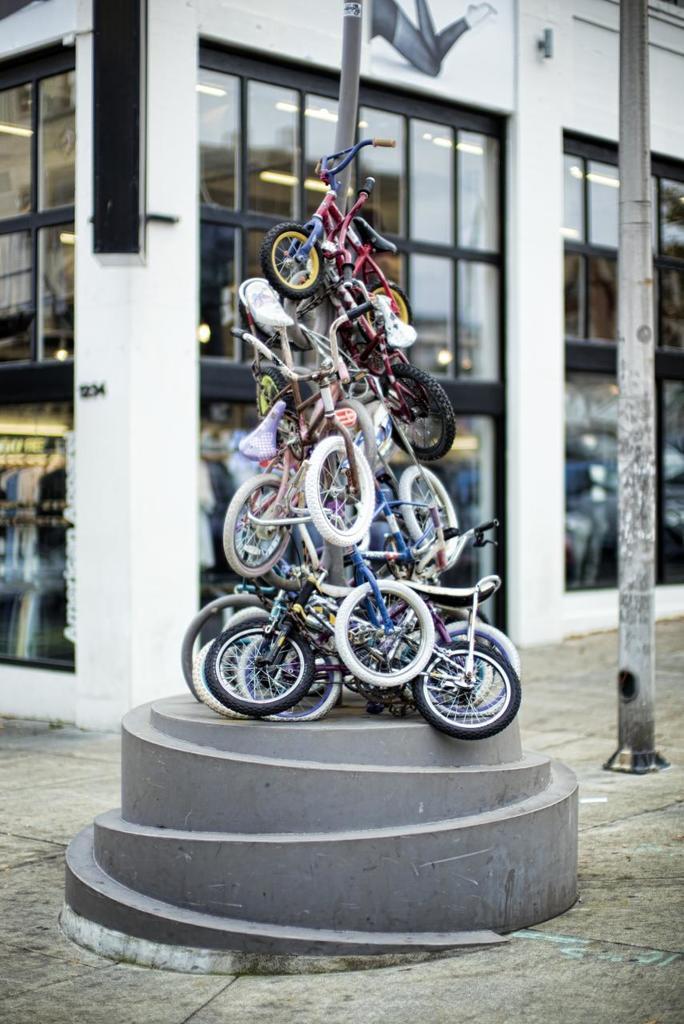Please provide a concise description of this image. In this images we can see small bicycles on a platform at the pole. In the background there is a buildings, glass doors, pole and through the glass doors we can see objects and lights on the ceiling. 